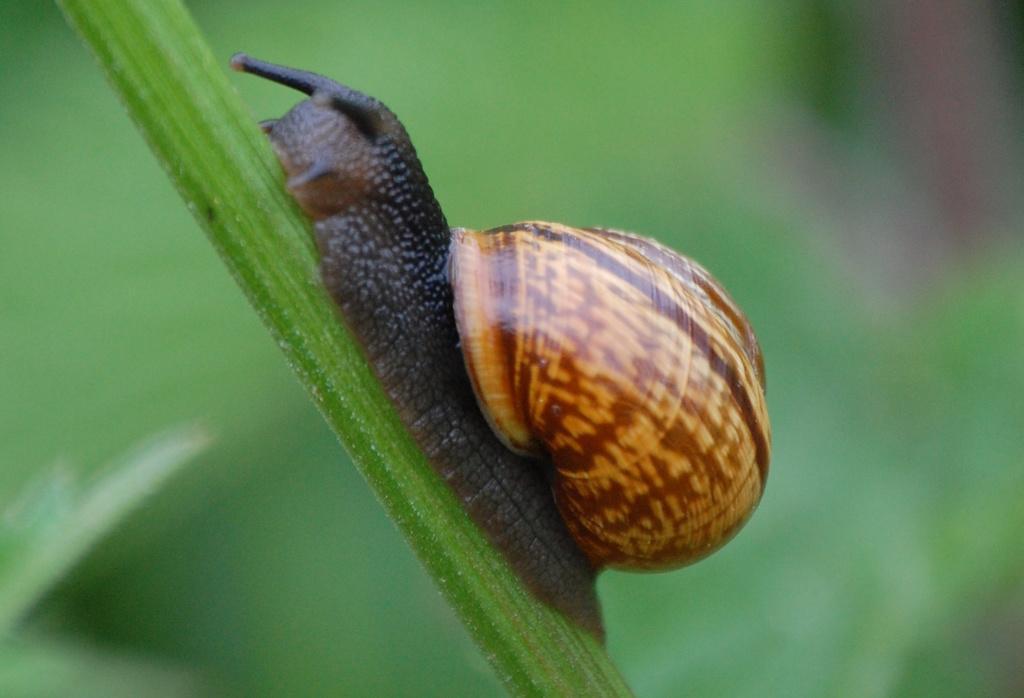Please provide a concise description of this image. In this image, we can see an animal on a green colored object. We can also see the blurred background. 